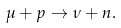Convert formula to latex. <formula><loc_0><loc_0><loc_500><loc_500>\mu + p \rightarrow \nu + n .</formula> 